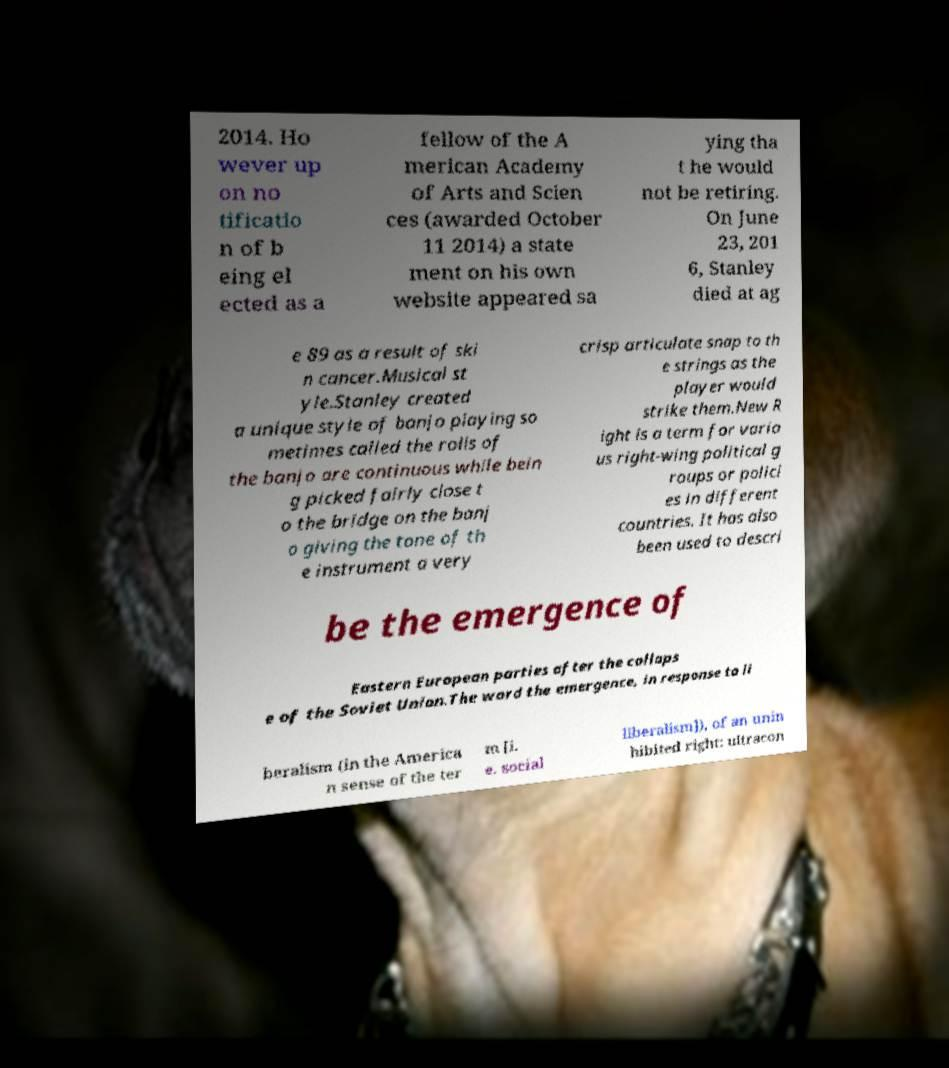Please read and relay the text visible in this image. What does it say? 2014. Ho wever up on no tificatio n of b eing el ected as a fellow of the A merican Academy of Arts and Scien ces (awarded October 11 2014) a state ment on his own website appeared sa ying tha t he would not be retiring. On June 23, 201 6, Stanley died at ag e 89 as a result of ski n cancer.Musical st yle.Stanley created a unique style of banjo playing so metimes called the rolls of the banjo are continuous while bein g picked fairly close t o the bridge on the banj o giving the tone of th e instrument a very crisp articulate snap to th e strings as the player would strike them.New R ight is a term for vario us right-wing political g roups or polici es in different countries. It has also been used to descri be the emergence of Eastern European parties after the collaps e of the Soviet Union.The word the emergence, in response to li beralism (in the America n sense of the ter m [i. e. social liberalism]), of an unin hibited right: ultracon 